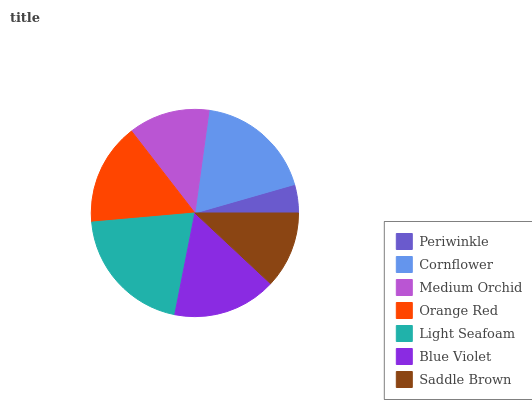Is Periwinkle the minimum?
Answer yes or no. Yes. Is Light Seafoam the maximum?
Answer yes or no. Yes. Is Cornflower the minimum?
Answer yes or no. No. Is Cornflower the maximum?
Answer yes or no. No. Is Cornflower greater than Periwinkle?
Answer yes or no. Yes. Is Periwinkle less than Cornflower?
Answer yes or no. Yes. Is Periwinkle greater than Cornflower?
Answer yes or no. No. Is Cornflower less than Periwinkle?
Answer yes or no. No. Is Orange Red the high median?
Answer yes or no. Yes. Is Orange Red the low median?
Answer yes or no. Yes. Is Medium Orchid the high median?
Answer yes or no. No. Is Blue Violet the low median?
Answer yes or no. No. 